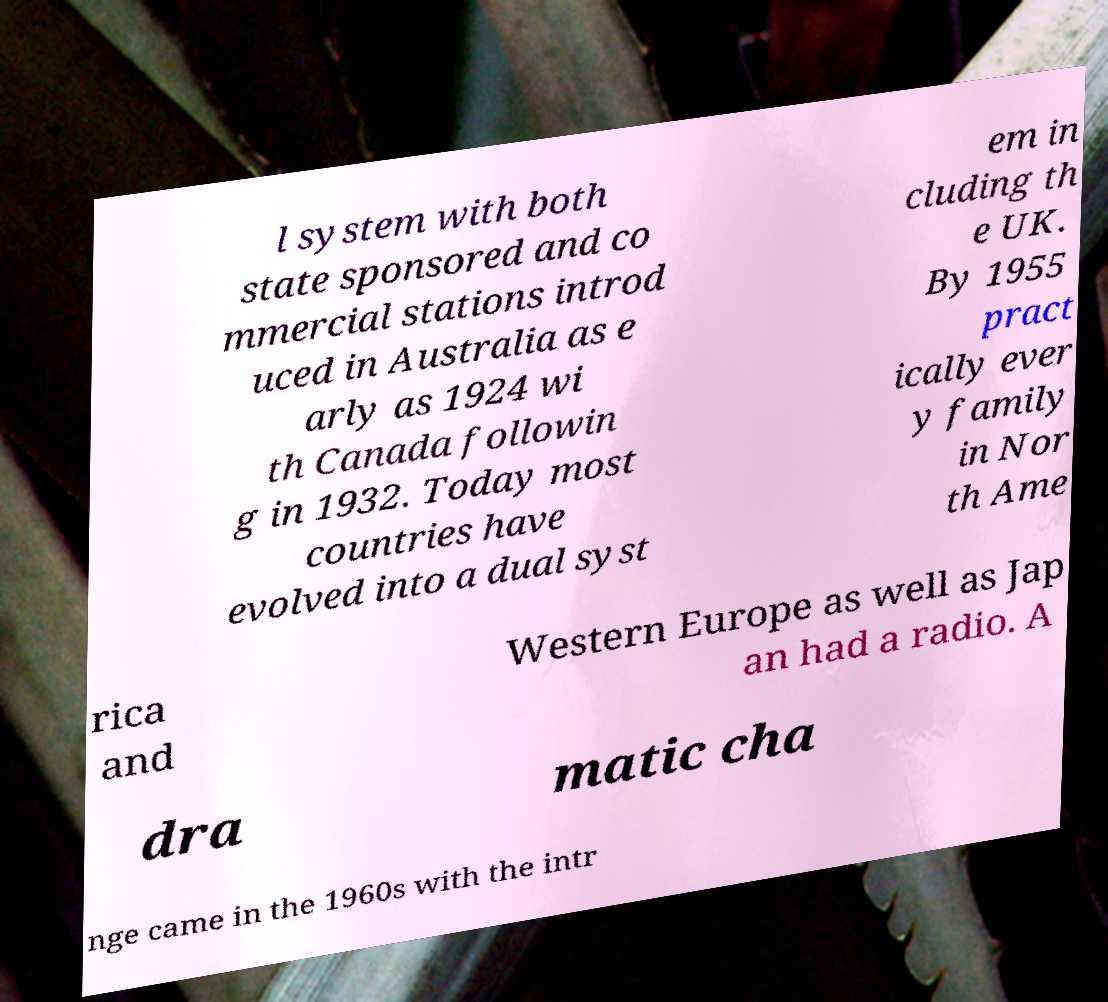Could you assist in decoding the text presented in this image and type it out clearly? l system with both state sponsored and co mmercial stations introd uced in Australia as e arly as 1924 wi th Canada followin g in 1932. Today most countries have evolved into a dual syst em in cluding th e UK. By 1955 pract ically ever y family in Nor th Ame rica and Western Europe as well as Jap an had a radio. A dra matic cha nge came in the 1960s with the intr 